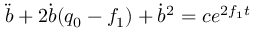Convert formula to latex. <formula><loc_0><loc_0><loc_500><loc_500>\ddot { b } + 2 \dot { b } ( q _ { 0 } - f _ { 1 } ) + \dot { b } ^ { 2 } = c e ^ { 2 f _ { 1 } t }</formula> 